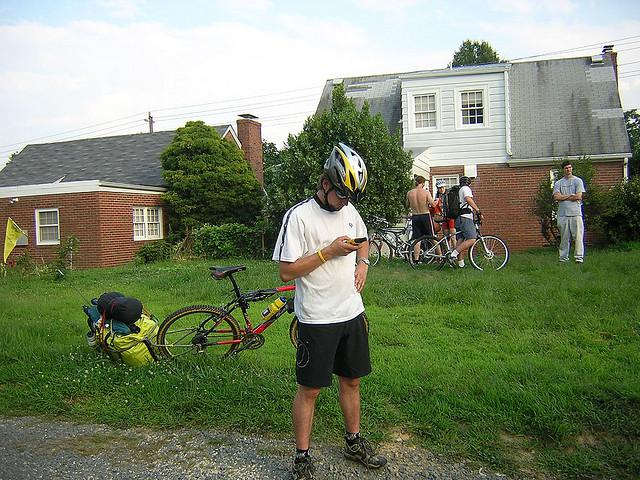Why is the man looking down at his hand? phone 